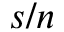<formula> <loc_0><loc_0><loc_500><loc_500>s / n</formula> 